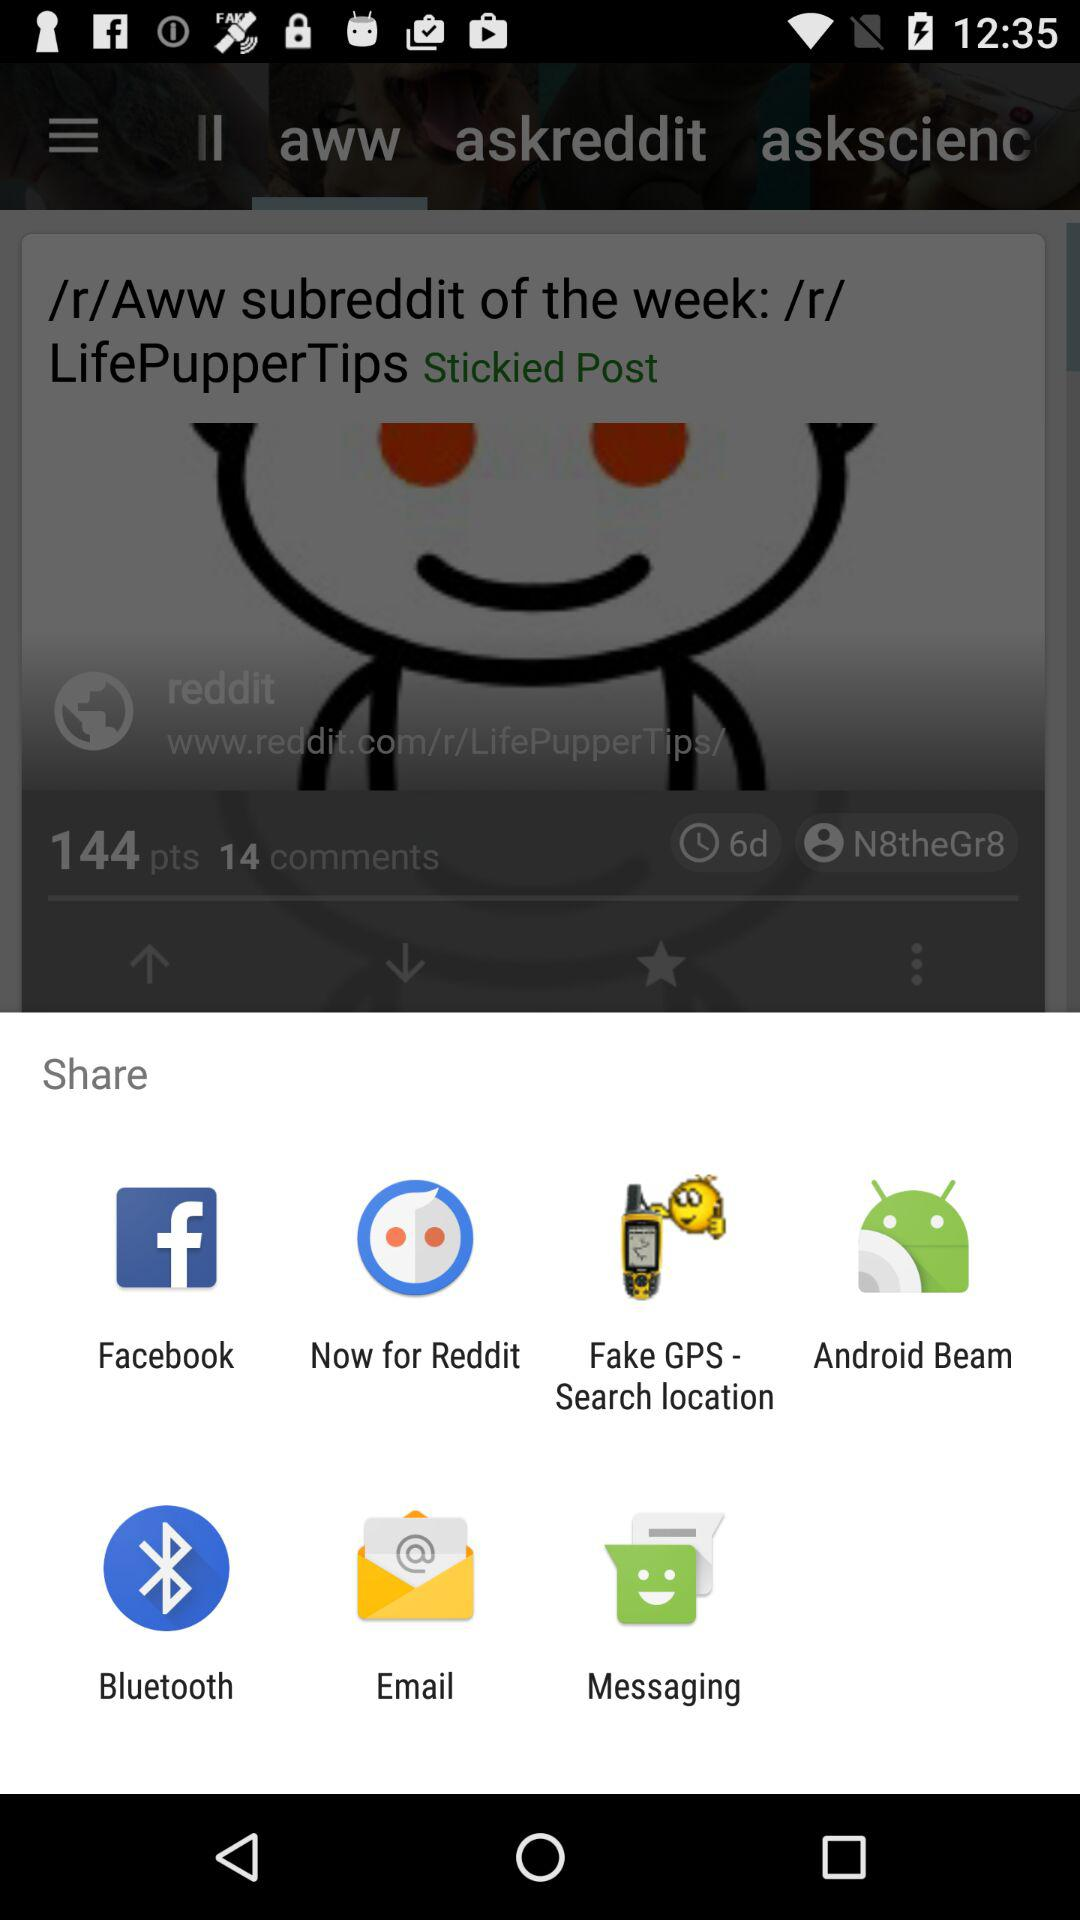How many posts are in "askreddit"?
When the provided information is insufficient, respond with <no answer>. <no answer> 